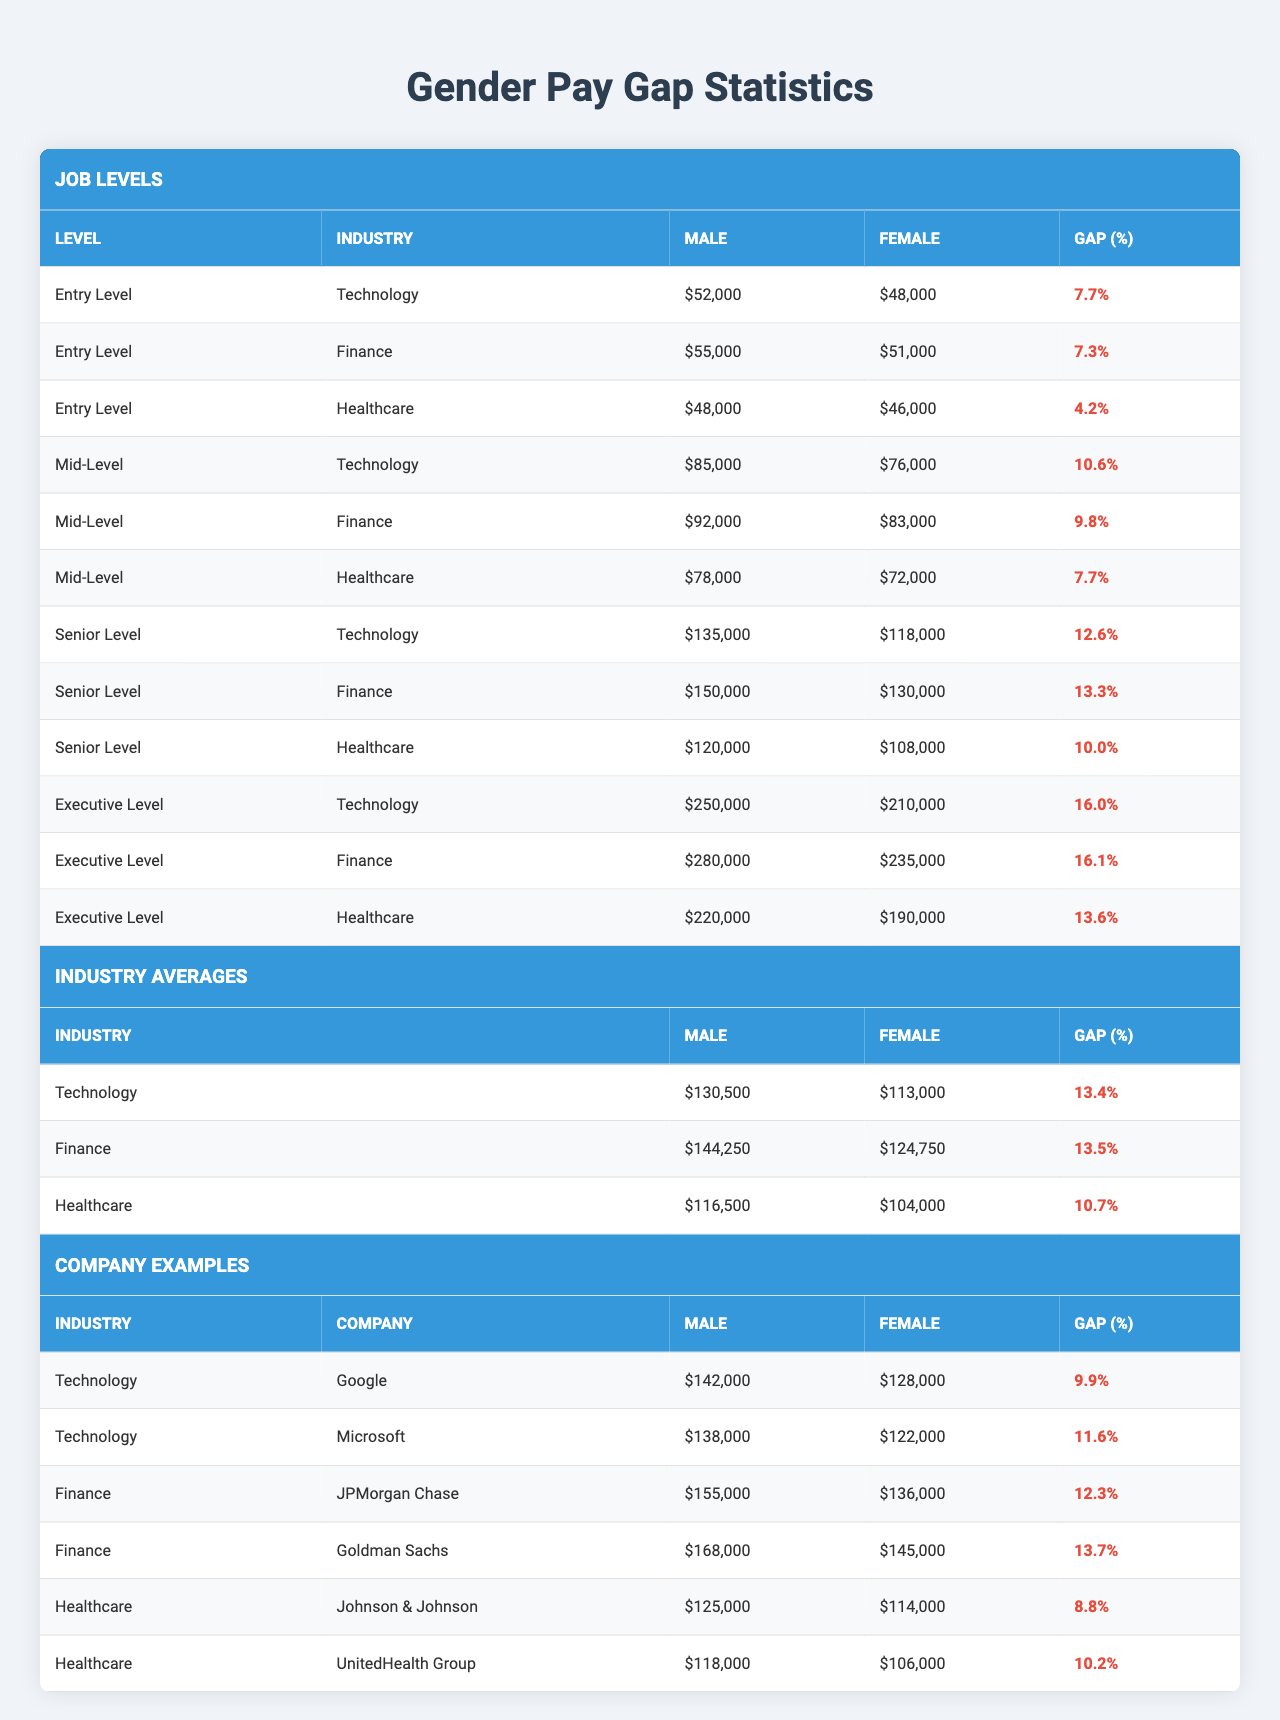What is the gender pay gap for entry-level positions in technology? In the technology sector for entry-level positions, males earn $52,000 and females earn $48,000. The gender pay gap is calculated as ((52,000 - 48,000) / 52,000) * 100 = 7.7%.
Answer: 7.7% Which job level has the highest gender pay gap in finance? In the finance sector, the gender pay gap for executive-level positions is 16.1%, which is higher than the gaps at entry-level (7.3%), mid-level (9.8%), and senior-level (13.3%).
Answer: Executive Level What is the average male salary across all industries at the senior level? The male salaries at the senior level are $135,000 (Technology), $150,000 (Finance), and $120,000 (Healthcare). The average is calculated as (135000 + 150000 + 120000) / 3 = 135000.
Answer: $135,000 For healthcare, what is the gender pay gap at the mid-level? In healthcare at the mid-level, males earn $78,000 while females earn $72,000. The gender pay gap is calculated as ((78,000 - 72,000) / 78,000) * 100 = 7.7%.
Answer: 7.7% In which company in the technology sector is the male salary the highest? The companies in the technology sector are Google ($142,000) and Microsoft ($138,000). Google has the highest male salary at $142,000.
Answer: Google Is the gender pay gap in healthcare larger than in technology at the executive level? In healthcare at the executive level, the pay gap is 13.6%. In technology, it is 16.0%. Since 16.0% > 13.6%, the gap in technology is larger.
Answer: No What is the difference in average female salary between finance and technology at the mid-level? The average female salaries at mid-level are $83,000 in finance and $76,000 in technology. The difference is $83,000 - $76,000 = $7,000.
Answer: $7,000 Which job level has the smallest gender pay gap in healthcare? Looking at healthcare across different job levels, the smallest gender pay gap is in entry level at 4.2%.
Answer: Entry Level What is the total average female salary across all industries in executive-level positions? At the executive level, the female salaries are $210,000 (Technology), $235,000 (Finance), and $190,000 (Healthcare). The total average is (210000 + 235000 + 190000) / 3 = 211000.
Answer: $211,000 Is the industry average male salary in technology higher than in healthcare? The average male salary in technology is $130,500, while in healthcare it is $116,500. Since $130,500 > $116,500, the average in technology is higher.
Answer: Yes 